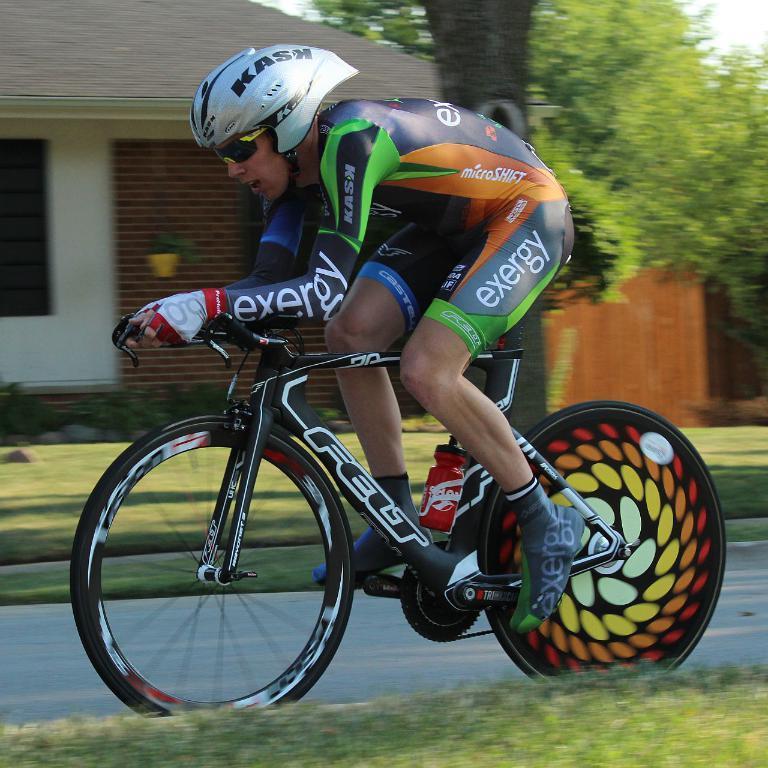Please provide a concise description of this image. In this picture, we see a man who is wearing the helmet is riding the bicycle. At the bottom, we see the grass and beside that, we see the road. On the right side, we see a door or a building in brown color. Behind that, we see the trees. On the left side, we see a flower pot and a building in white and brown color with a grey color roof. 